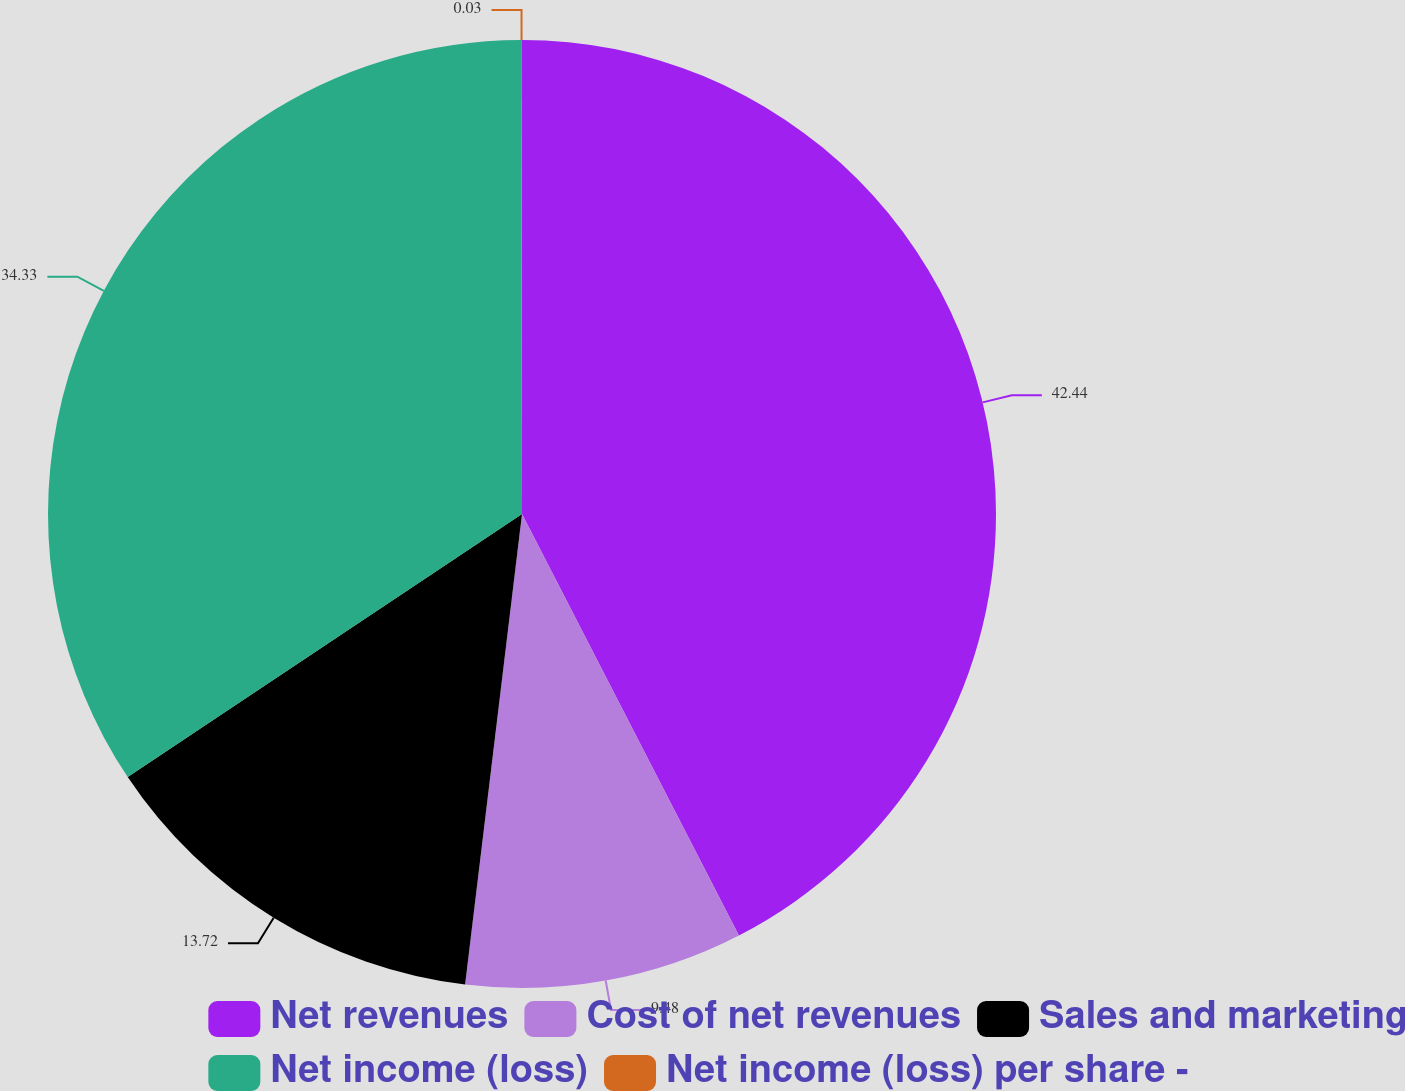<chart> <loc_0><loc_0><loc_500><loc_500><pie_chart><fcel>Net revenues<fcel>Cost of net revenues<fcel>Sales and marketing<fcel>Net income (loss)<fcel>Net income (loss) per share -<nl><fcel>42.43%<fcel>9.48%<fcel>13.72%<fcel>34.33%<fcel>0.03%<nl></chart> 